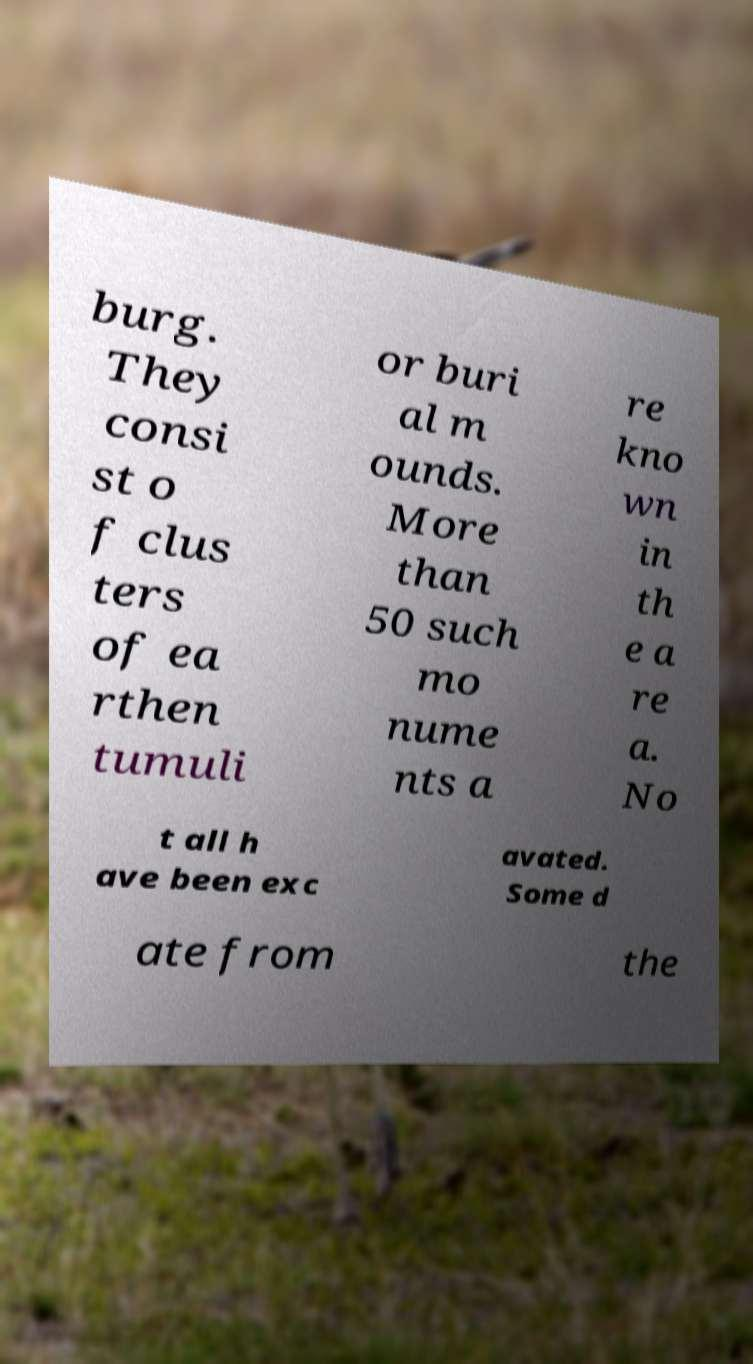Could you extract and type out the text from this image? burg. They consi st o f clus ters of ea rthen tumuli or buri al m ounds. More than 50 such mo nume nts a re kno wn in th e a re a. No t all h ave been exc avated. Some d ate from the 